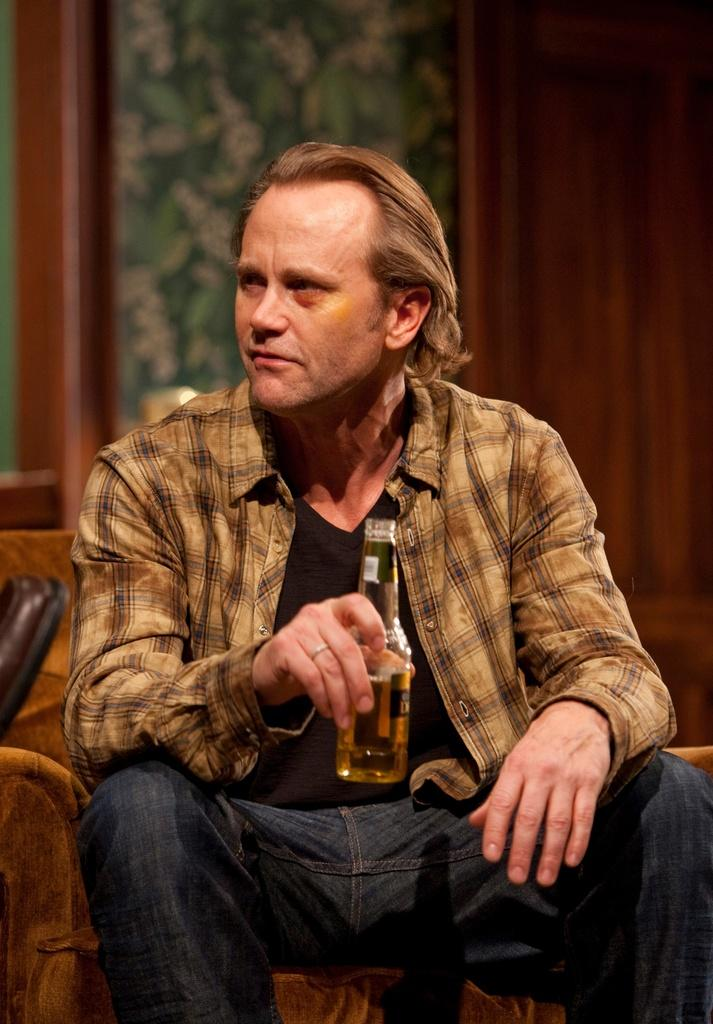What is the main subject of the image? The main subject of the image is a man. What is the man doing in the image? The man is sitting in the image. What object is the man holding in the image? The man is holding a bottle in the image. What type of cheese is the man eating in the image? There is no cheese present in the image; the man is holding a bottle. 